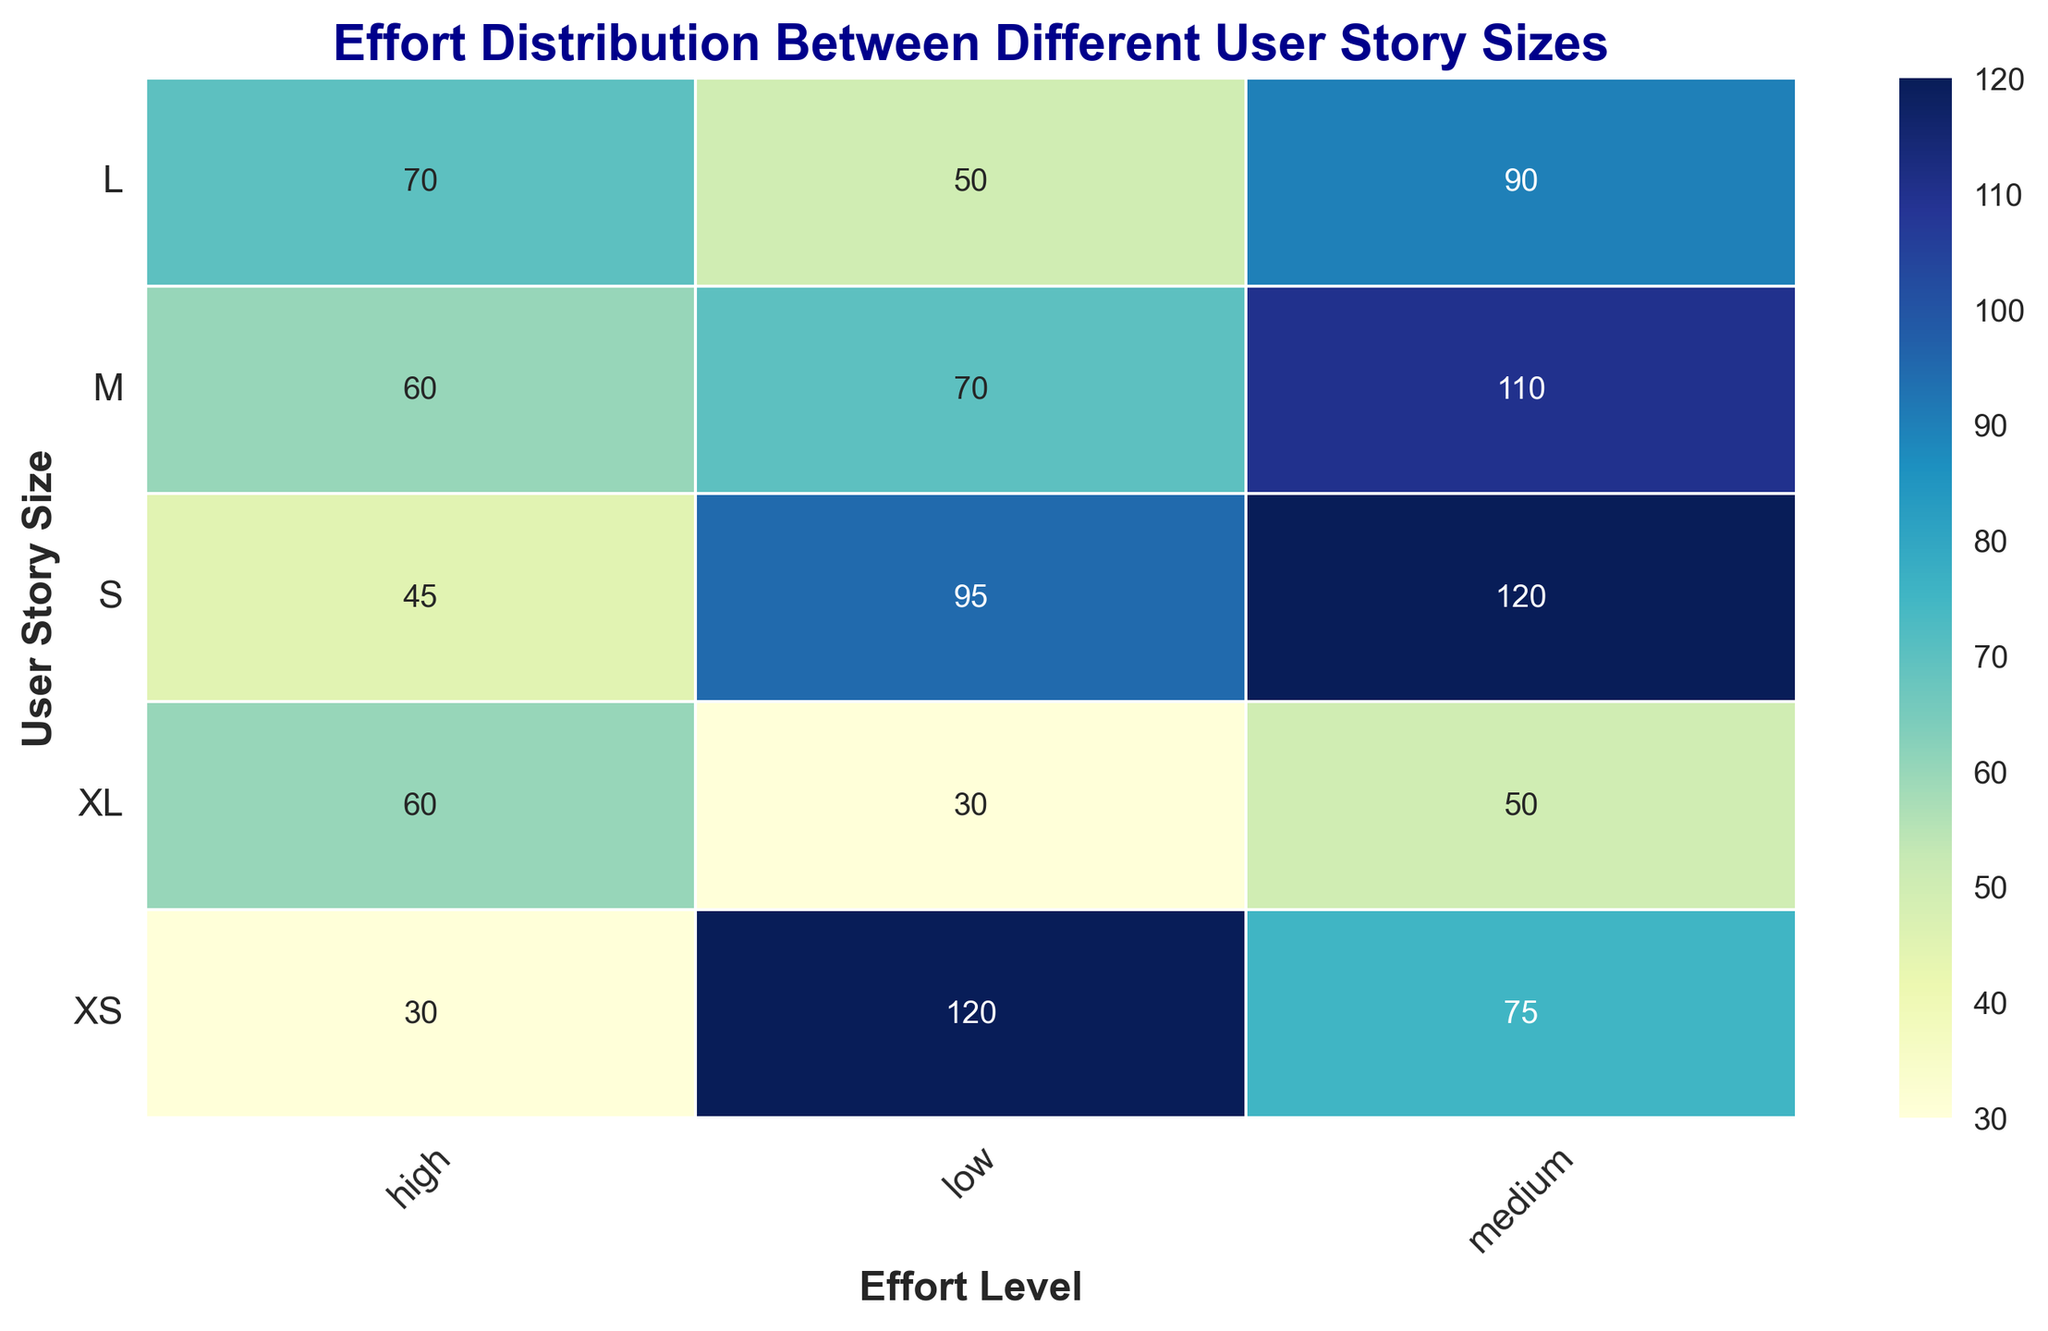Which user story size has the highest frequency for medium effort level? By observing the medium effort level column, the 'S' story size has the highest frequency, which is 120.
Answer: S What is the total frequency for high effort level across all user story sizes? Sum the frequencies in the high effort level column (30 + 45 + 60 + 70 + 60) to get 265.
Answer: 265 How does the frequency of low effort level for XL user stories compare to the frequency of medium effort level for XS user stories? The frequency of low effort for XL (30) is less than the frequency of medium effort for XS (75).
Answer: Less For which effort level does the S user story size have the highest frequency? Check the frequencies for S in all effort levels; it is highest for medium effort with a frequency of 120.
Answer: Medium Which user story size has a higher frequency at high effort level: M or L? Compare the high effort frequencies of M (60) and L (70); L has the higher frequency.
Answer: L What is the average frequency of medium effort level across all user story sizes? Sum the frequencies of medium effort level (75 + 120 + 110 + 90 + 50) which equals 445, then divide by the number of story sizes (5). The average is 445/5 = 89.
Answer: 89 